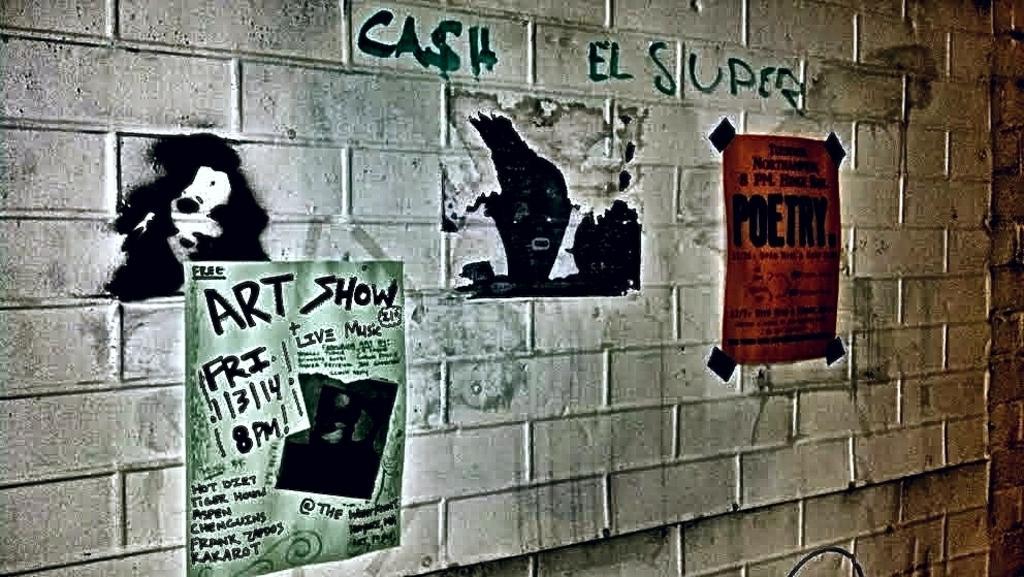Can you describe this image briefly? In this image we can see a wall. There are two posters on the wall. There is some painting and some text on the wall. 